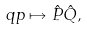<formula> <loc_0><loc_0><loc_500><loc_500>q p \mapsto \hat { P } \hat { Q } ,</formula> 